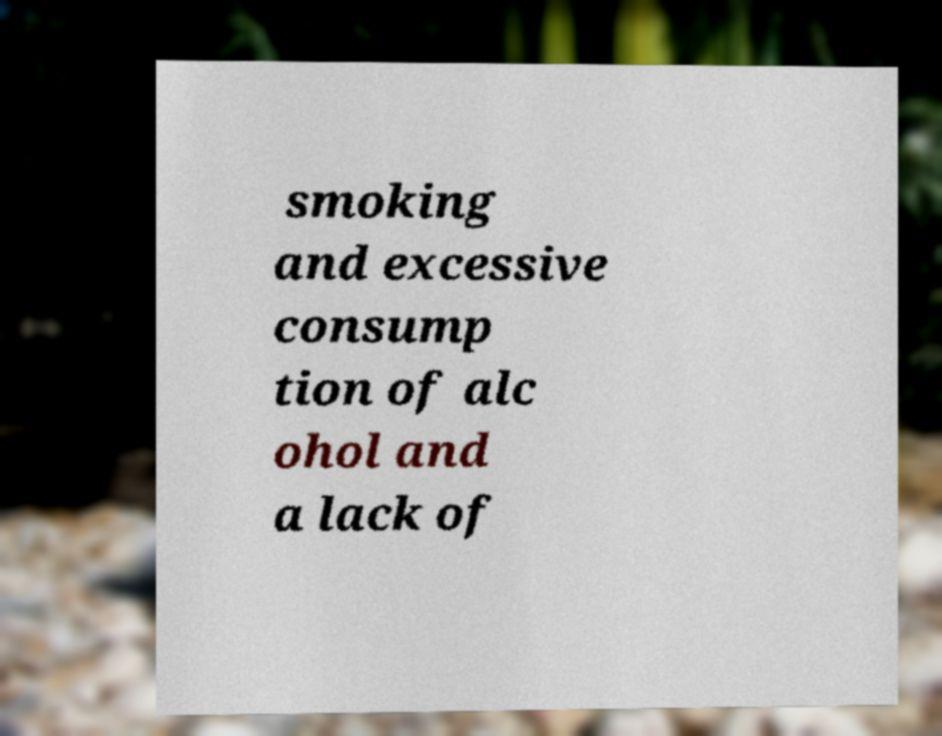Could you assist in decoding the text presented in this image and type it out clearly? smoking and excessive consump tion of alc ohol and a lack of 